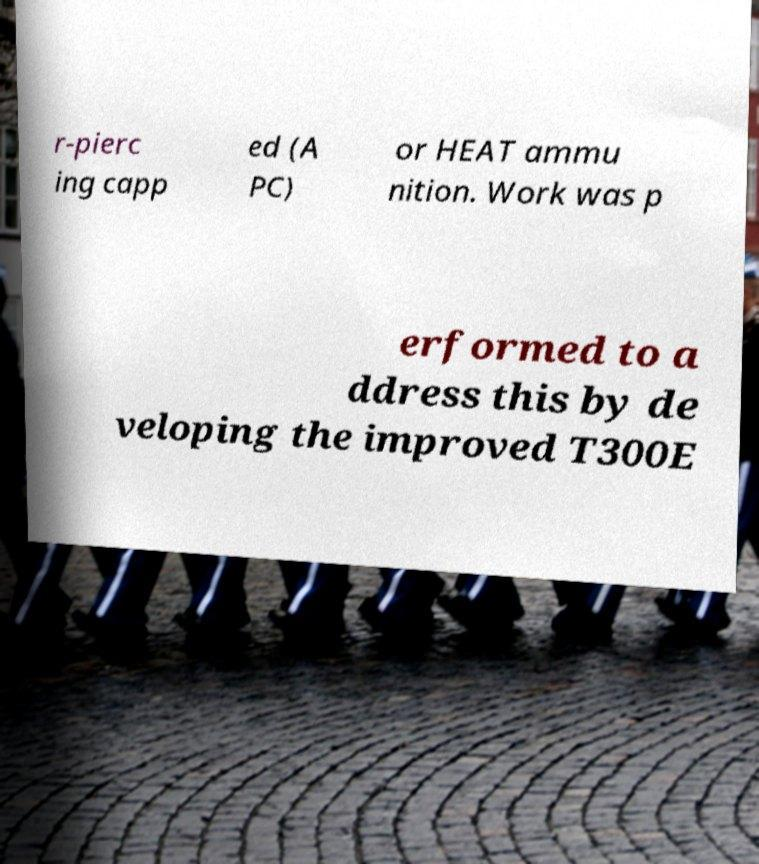Could you extract and type out the text from this image? r-pierc ing capp ed (A PC) or HEAT ammu nition. Work was p erformed to a ddress this by de veloping the improved T300E 